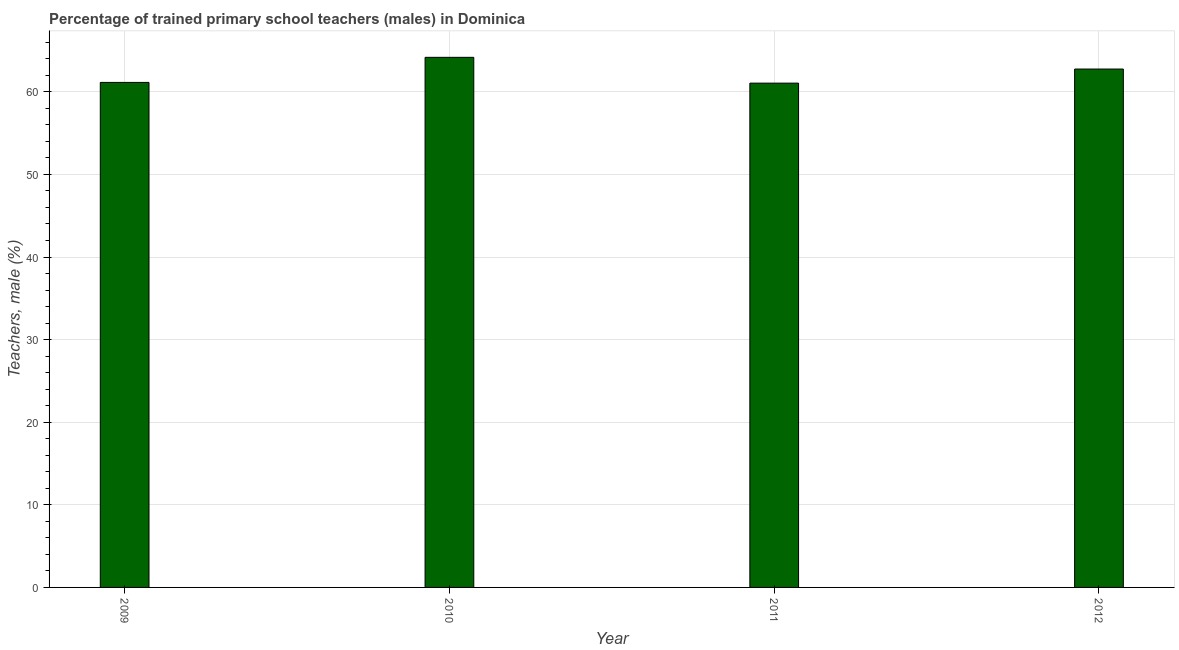Does the graph contain grids?
Offer a very short reply. Yes. What is the title of the graph?
Your response must be concise. Percentage of trained primary school teachers (males) in Dominica. What is the label or title of the Y-axis?
Offer a terse response. Teachers, male (%). What is the percentage of trained male teachers in 2009?
Your answer should be compact. 61.14. Across all years, what is the maximum percentage of trained male teachers?
Keep it short and to the point. 64.17. Across all years, what is the minimum percentage of trained male teachers?
Offer a terse response. 61.05. In which year was the percentage of trained male teachers minimum?
Provide a short and direct response. 2011. What is the sum of the percentage of trained male teachers?
Your response must be concise. 249.11. What is the difference between the percentage of trained male teachers in 2010 and 2011?
Offer a very short reply. 3.12. What is the average percentage of trained male teachers per year?
Your answer should be very brief. 62.28. What is the median percentage of trained male teachers?
Ensure brevity in your answer.  61.95. What is the ratio of the percentage of trained male teachers in 2010 to that in 2012?
Keep it short and to the point. 1.02. Is the percentage of trained male teachers in 2009 less than that in 2010?
Ensure brevity in your answer.  Yes. Is the difference between the percentage of trained male teachers in 2010 and 2012 greater than the difference between any two years?
Provide a succinct answer. No. What is the difference between the highest and the second highest percentage of trained male teachers?
Your answer should be compact. 1.42. Is the sum of the percentage of trained male teachers in 2010 and 2012 greater than the maximum percentage of trained male teachers across all years?
Provide a short and direct response. Yes. What is the difference between the highest and the lowest percentage of trained male teachers?
Offer a very short reply. 3.12. What is the difference between two consecutive major ticks on the Y-axis?
Offer a very short reply. 10. Are the values on the major ticks of Y-axis written in scientific E-notation?
Your answer should be very brief. No. What is the Teachers, male (%) in 2009?
Your answer should be compact. 61.14. What is the Teachers, male (%) of 2010?
Ensure brevity in your answer.  64.17. What is the Teachers, male (%) of 2011?
Give a very brief answer. 61.05. What is the Teachers, male (%) in 2012?
Your answer should be very brief. 62.75. What is the difference between the Teachers, male (%) in 2009 and 2010?
Ensure brevity in your answer.  -3.04. What is the difference between the Teachers, male (%) in 2009 and 2011?
Ensure brevity in your answer.  0.09. What is the difference between the Teachers, male (%) in 2009 and 2012?
Provide a short and direct response. -1.62. What is the difference between the Teachers, male (%) in 2010 and 2011?
Offer a terse response. 3.12. What is the difference between the Teachers, male (%) in 2010 and 2012?
Keep it short and to the point. 1.42. What is the difference between the Teachers, male (%) in 2011 and 2012?
Provide a short and direct response. -1.71. What is the ratio of the Teachers, male (%) in 2009 to that in 2010?
Offer a very short reply. 0.95. What is the ratio of the Teachers, male (%) in 2009 to that in 2012?
Keep it short and to the point. 0.97. What is the ratio of the Teachers, male (%) in 2010 to that in 2011?
Keep it short and to the point. 1.05. 